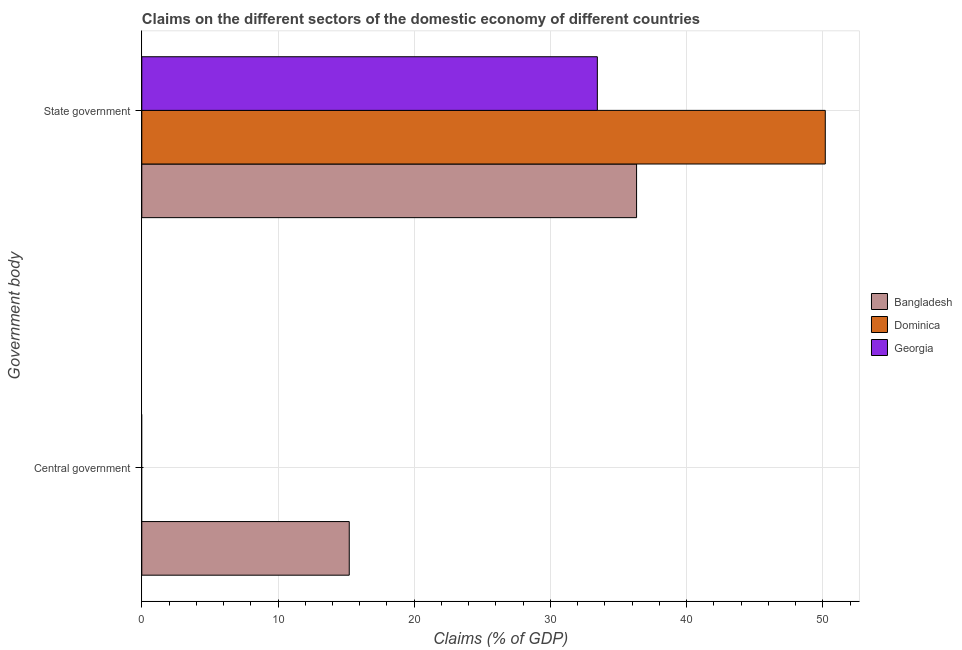How many different coloured bars are there?
Ensure brevity in your answer.  3. Are the number of bars per tick equal to the number of legend labels?
Your answer should be very brief. No. How many bars are there on the 2nd tick from the bottom?
Give a very brief answer. 3. What is the label of the 2nd group of bars from the top?
Ensure brevity in your answer.  Central government. Across all countries, what is the maximum claims on state government?
Offer a very short reply. 50.18. Across all countries, what is the minimum claims on state government?
Provide a short and direct response. 33.44. In which country was the claims on state government maximum?
Offer a very short reply. Dominica. What is the total claims on state government in the graph?
Provide a succinct answer. 119.94. What is the difference between the claims on state government in Bangladesh and that in Georgia?
Ensure brevity in your answer.  2.88. What is the difference between the claims on central government in Georgia and the claims on state government in Bangladesh?
Ensure brevity in your answer.  -36.32. What is the average claims on central government per country?
Your answer should be compact. 5.08. What is the difference between the claims on state government and claims on central government in Bangladesh?
Make the answer very short. 21.09. What is the ratio of the claims on state government in Bangladesh to that in Georgia?
Your response must be concise. 1.09. Is the claims on state government in Georgia less than that in Dominica?
Your response must be concise. Yes. Are the values on the major ticks of X-axis written in scientific E-notation?
Make the answer very short. No. How many legend labels are there?
Your answer should be very brief. 3. How are the legend labels stacked?
Provide a short and direct response. Vertical. What is the title of the graph?
Provide a short and direct response. Claims on the different sectors of the domestic economy of different countries. What is the label or title of the X-axis?
Provide a succinct answer. Claims (% of GDP). What is the label or title of the Y-axis?
Ensure brevity in your answer.  Government body. What is the Claims (% of GDP) of Bangladesh in Central government?
Offer a very short reply. 15.23. What is the Claims (% of GDP) in Georgia in Central government?
Provide a succinct answer. 0. What is the Claims (% of GDP) of Bangladesh in State government?
Keep it short and to the point. 36.32. What is the Claims (% of GDP) of Dominica in State government?
Ensure brevity in your answer.  50.18. What is the Claims (% of GDP) of Georgia in State government?
Your answer should be very brief. 33.44. Across all Government body, what is the maximum Claims (% of GDP) in Bangladesh?
Offer a very short reply. 36.32. Across all Government body, what is the maximum Claims (% of GDP) of Dominica?
Offer a very short reply. 50.18. Across all Government body, what is the maximum Claims (% of GDP) in Georgia?
Offer a very short reply. 33.44. Across all Government body, what is the minimum Claims (% of GDP) of Bangladesh?
Make the answer very short. 15.23. Across all Government body, what is the minimum Claims (% of GDP) in Dominica?
Your answer should be very brief. 0. What is the total Claims (% of GDP) of Bangladesh in the graph?
Make the answer very short. 51.55. What is the total Claims (% of GDP) in Dominica in the graph?
Provide a succinct answer. 50.18. What is the total Claims (% of GDP) in Georgia in the graph?
Your answer should be compact. 33.44. What is the difference between the Claims (% of GDP) in Bangladesh in Central government and that in State government?
Make the answer very short. -21.09. What is the difference between the Claims (% of GDP) in Bangladesh in Central government and the Claims (% of GDP) in Dominica in State government?
Keep it short and to the point. -34.95. What is the difference between the Claims (% of GDP) in Bangladesh in Central government and the Claims (% of GDP) in Georgia in State government?
Offer a terse response. -18.21. What is the average Claims (% of GDP) of Bangladesh per Government body?
Your answer should be very brief. 25.78. What is the average Claims (% of GDP) of Dominica per Government body?
Provide a succinct answer. 25.09. What is the average Claims (% of GDP) in Georgia per Government body?
Keep it short and to the point. 16.72. What is the difference between the Claims (% of GDP) in Bangladesh and Claims (% of GDP) in Dominica in State government?
Your answer should be very brief. -13.85. What is the difference between the Claims (% of GDP) of Bangladesh and Claims (% of GDP) of Georgia in State government?
Your answer should be compact. 2.88. What is the difference between the Claims (% of GDP) in Dominica and Claims (% of GDP) in Georgia in State government?
Offer a terse response. 16.73. What is the ratio of the Claims (% of GDP) in Bangladesh in Central government to that in State government?
Give a very brief answer. 0.42. What is the difference between the highest and the second highest Claims (% of GDP) of Bangladesh?
Your response must be concise. 21.09. What is the difference between the highest and the lowest Claims (% of GDP) in Bangladesh?
Your answer should be compact. 21.09. What is the difference between the highest and the lowest Claims (% of GDP) in Dominica?
Give a very brief answer. 50.18. What is the difference between the highest and the lowest Claims (% of GDP) in Georgia?
Provide a succinct answer. 33.44. 